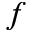<formula> <loc_0><loc_0><loc_500><loc_500>f</formula> 